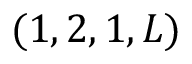<formula> <loc_0><loc_0><loc_500><loc_500>( 1 , 2 , 1 , L )</formula> 